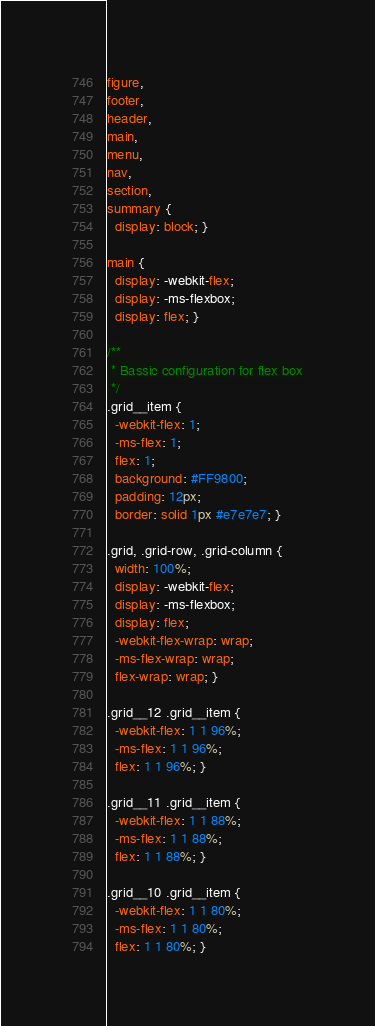<code> <loc_0><loc_0><loc_500><loc_500><_CSS_>figure,
footer,
header,
main,
menu,
nav,
section,
summary {
  display: block; }

main {
  display: -webkit-flex;
  display: -ms-flexbox;
  display: flex; }

/**
 * Bassic configuration for flex box
 */
.grid__item {
  -webkit-flex: 1;
  -ms-flex: 1;
  flex: 1;
  background: #FF9800;
  padding: 12px;
  border: solid 1px #e7e7e7; }

.grid, .grid-row, .grid-column {
  width: 100%;
  display: -webkit-flex;
  display: -ms-flexbox;
  display: flex;
  -webkit-flex-wrap: wrap;
  -ms-flex-wrap: wrap;
  flex-wrap: wrap; }

.grid__12 .grid__item {
  -webkit-flex: 1 1 96%;
  -ms-flex: 1 1 96%;
  flex: 1 1 96%; }

.grid__11 .grid__item {
  -webkit-flex: 1 1 88%;
  -ms-flex: 1 1 88%;
  flex: 1 1 88%; }

.grid__10 .grid__item {
  -webkit-flex: 1 1 80%;
  -ms-flex: 1 1 80%;
  flex: 1 1 80%; }
</code> 